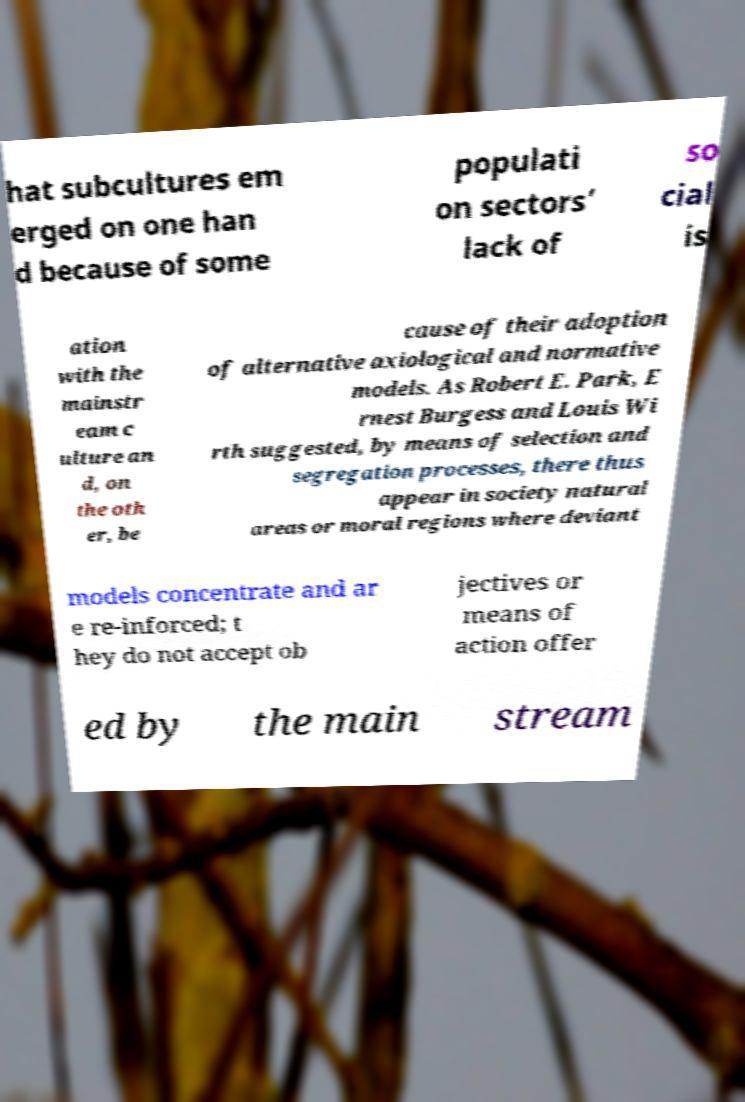Could you extract and type out the text from this image? hat subcultures em erged on one han d because of some populati on sectors’ lack of so cial is ation with the mainstr eam c ulture an d, on the oth er, be cause of their adoption of alternative axiological and normative models. As Robert E. Park, E rnest Burgess and Louis Wi rth suggested, by means of selection and segregation processes, there thus appear in society natural areas or moral regions where deviant models concentrate and ar e re-inforced; t hey do not accept ob jectives or means of action offer ed by the main stream 